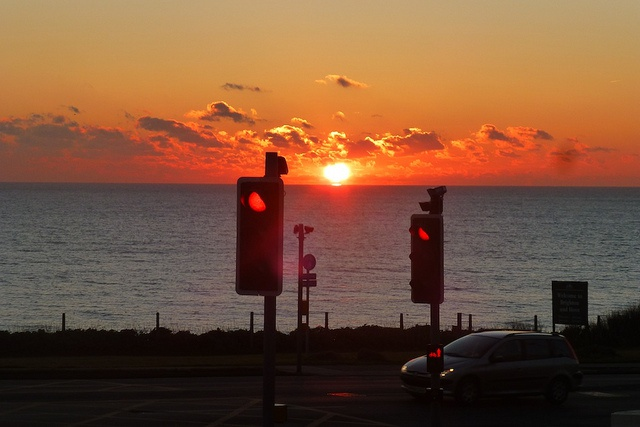Describe the objects in this image and their specific colors. I can see car in tan, black, gray, and maroon tones, traffic light in tan, black, maroon, red, and gray tones, and traffic light in tan, black, maroon, red, and brown tones in this image. 